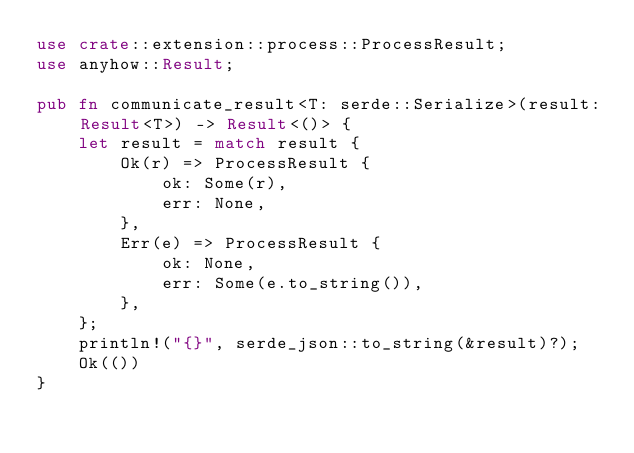<code> <loc_0><loc_0><loc_500><loc_500><_Rust_>use crate::extension::process::ProcessResult;
use anyhow::Result;

pub fn communicate_result<T: serde::Serialize>(result: Result<T>) -> Result<()> {
    let result = match result {
        Ok(r) => ProcessResult {
            ok: Some(r),
            err: None,
        },
        Err(e) => ProcessResult {
            ok: None,
            err: Some(e.to_string()),
        },
    };
    println!("{}", serde_json::to_string(&result)?);
    Ok(())
}
</code> 